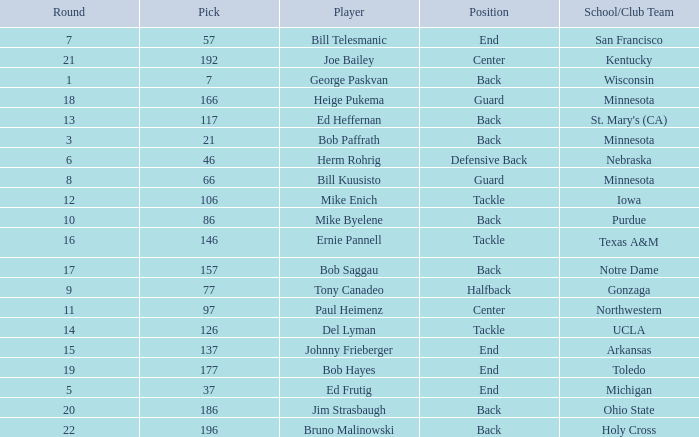What was the highest pick for a player from a school or club team of Arkansas? 137.0. Could you parse the entire table as a dict? {'header': ['Round', 'Pick', 'Player', 'Position', 'School/Club Team'], 'rows': [['7', '57', 'Bill Telesmanic', 'End', 'San Francisco'], ['21', '192', 'Joe Bailey', 'Center', 'Kentucky'], ['1', '7', 'George Paskvan', 'Back', 'Wisconsin'], ['18', '166', 'Heige Pukema', 'Guard', 'Minnesota'], ['13', '117', 'Ed Heffernan', 'Back', "St. Mary's (CA)"], ['3', '21', 'Bob Paffrath', 'Back', 'Minnesota'], ['6', '46', 'Herm Rohrig', 'Defensive Back', 'Nebraska'], ['8', '66', 'Bill Kuusisto', 'Guard', 'Minnesota'], ['12', '106', 'Mike Enich', 'Tackle', 'Iowa'], ['10', '86', 'Mike Byelene', 'Back', 'Purdue'], ['16', '146', 'Ernie Pannell', 'Tackle', 'Texas A&M'], ['17', '157', 'Bob Saggau', 'Back', 'Notre Dame'], ['9', '77', 'Tony Canadeo', 'Halfback', 'Gonzaga'], ['11', '97', 'Paul Heimenz', 'Center', 'Northwestern'], ['14', '126', 'Del Lyman', 'Tackle', 'UCLA'], ['15', '137', 'Johnny Frieberger', 'End', 'Arkansas'], ['19', '177', 'Bob Hayes', 'End', 'Toledo'], ['5', '37', 'Ed Frutig', 'End', 'Michigan'], ['20', '186', 'Jim Strasbaugh', 'Back', 'Ohio State'], ['22', '196', 'Bruno Malinowski', 'Back', 'Holy Cross']]} 